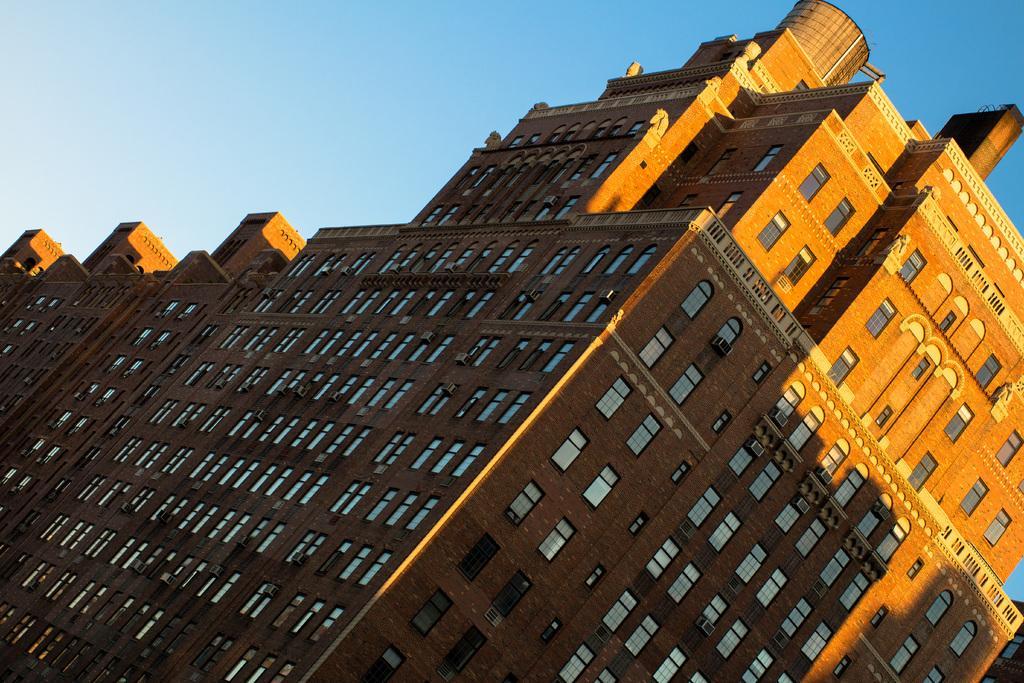In one or two sentences, can you explain what this image depicts? In this image we can see the buildings. We can also see the sky. Glass windows and air conditioners are also visible in this image. 